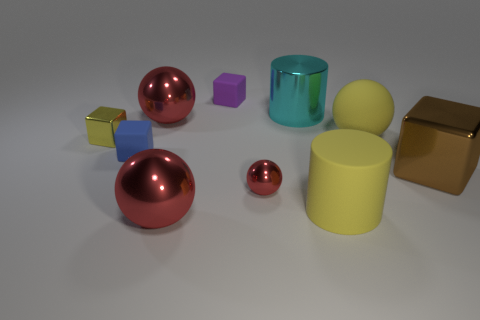What can you infer about the setting from the shadows cast by the objects? The shadows in the image are soft-edged and fall to the right of the objects, which indicates a light source positioned to the left of the scene. The uniformity of the shadow directions suggests a single light source. The setting is likely a controlled environment where the light and placement of objects have been carefully arranged. 